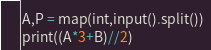Convert code to text. <code><loc_0><loc_0><loc_500><loc_500><_Python_>A,P = map(int,input().split())
print((A*3+B)//2)

</code> 